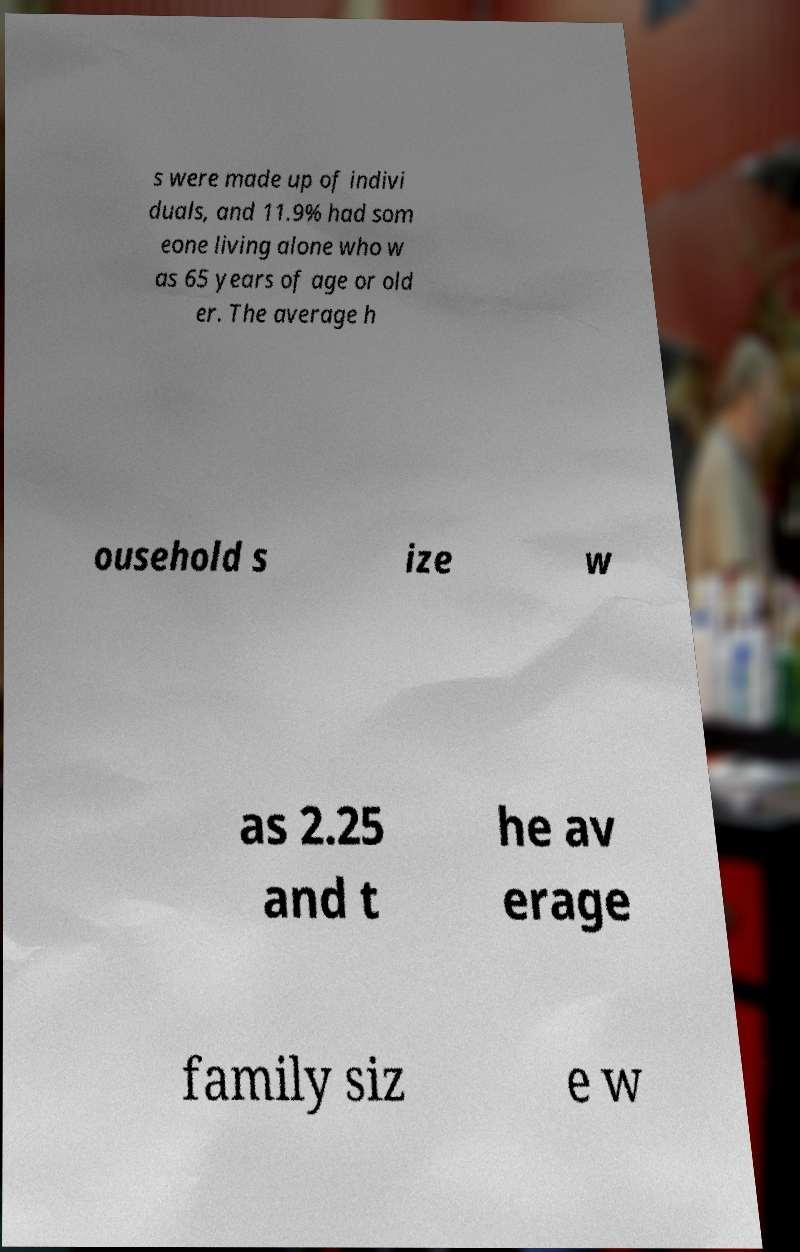Can you read and provide the text displayed in the image?This photo seems to have some interesting text. Can you extract and type it out for me? s were made up of indivi duals, and 11.9% had som eone living alone who w as 65 years of age or old er. The average h ousehold s ize w as 2.25 and t he av erage family siz e w 